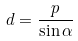Convert formula to latex. <formula><loc_0><loc_0><loc_500><loc_500>d = \frac { p } { \sin \alpha }</formula> 